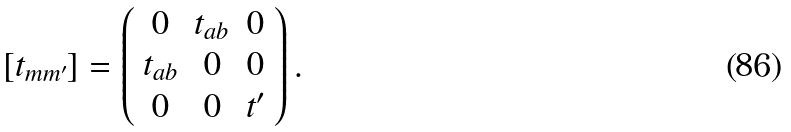<formula> <loc_0><loc_0><loc_500><loc_500>[ t _ { m m ^ { \prime } } ] = \left ( \begin{array} { c c c } 0 & t _ { a b } & 0 \\ t _ { a b } & 0 & 0 \\ 0 & 0 & t ^ { \prime } \end{array} \right ) .</formula> 